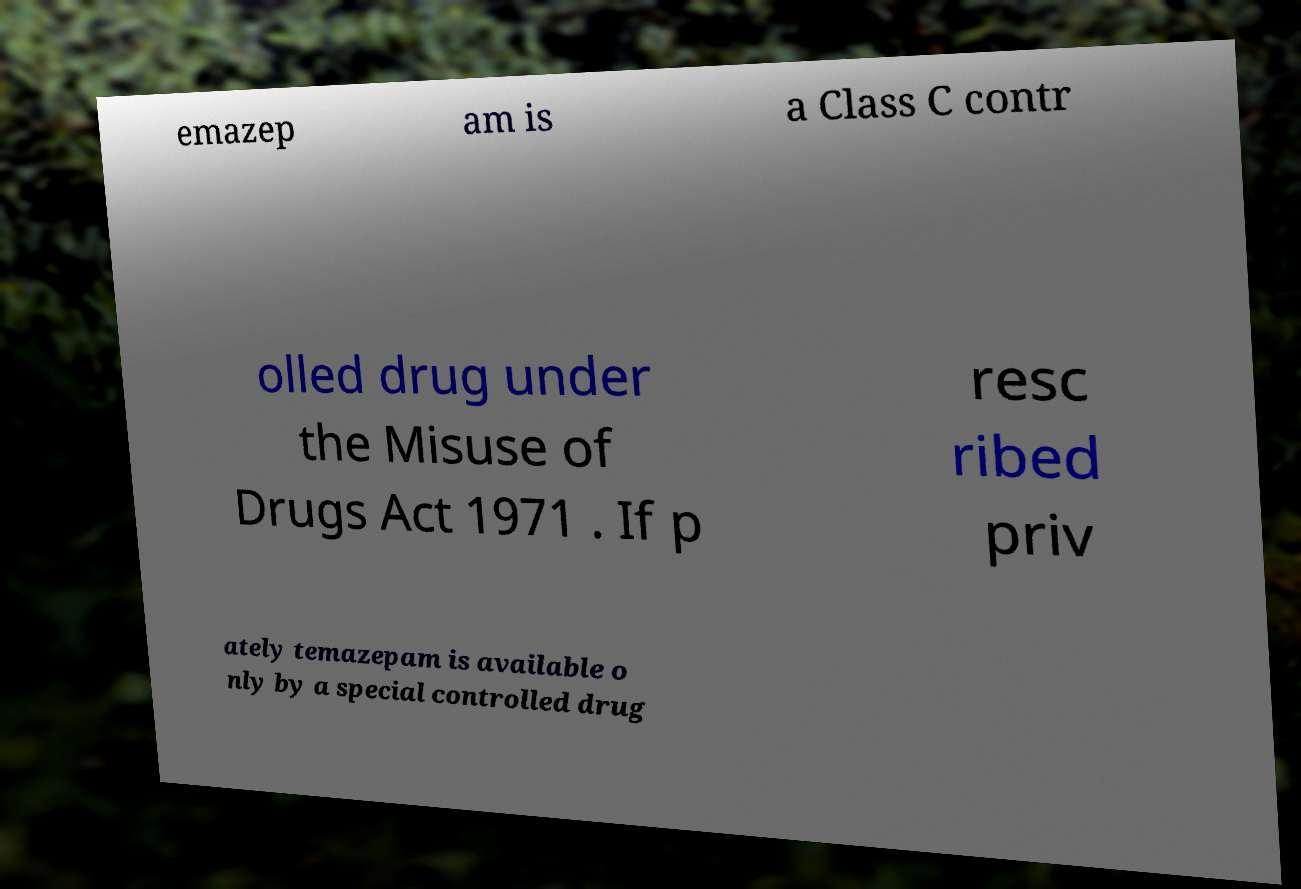I need the written content from this picture converted into text. Can you do that? emazep am is a Class C contr olled drug under the Misuse of Drugs Act 1971 . If p resc ribed priv ately temazepam is available o nly by a special controlled drug 